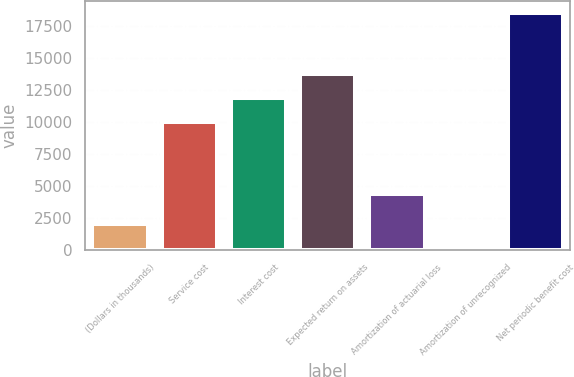<chart> <loc_0><loc_0><loc_500><loc_500><bar_chart><fcel>(Dollars in thousands)<fcel>Service cost<fcel>Interest cost<fcel>Expected return on assets<fcel>Amortization of actuarial loss<fcel>Amortization of unrecognized<fcel>Net periodic benefit cost<nl><fcel>2014<fcel>10015<fcel>11864.4<fcel>13713.8<fcel>4341<fcel>49<fcel>18543<nl></chart> 